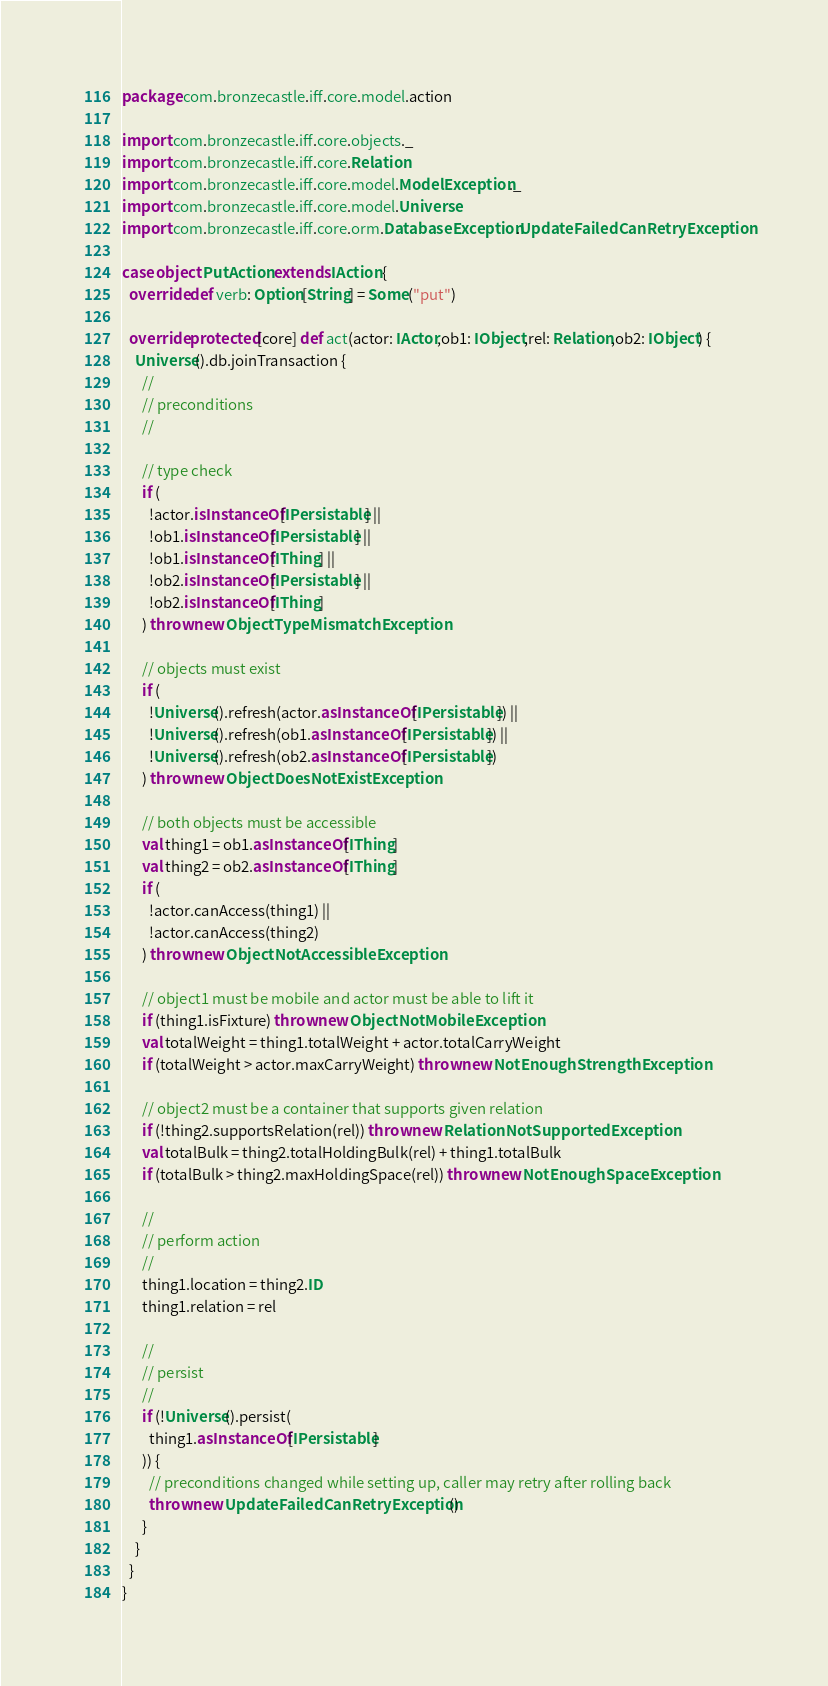<code> <loc_0><loc_0><loc_500><loc_500><_Scala_>package com.bronzecastle.iff.core.model.action

import com.bronzecastle.iff.core.objects._
import com.bronzecastle.iff.core.Relation
import com.bronzecastle.iff.core.model.ModelException._
import com.bronzecastle.iff.core.model.Universe
import com.bronzecastle.iff.core.orm.DatabaseException.UpdateFailedCanRetryException

case object PutAction extends IAction {
  override def verb: Option[String] = Some("put")

  override protected[core] def act(actor: IActor,ob1: IObject,rel: Relation,ob2: IObject) {
    Universe().db.joinTransaction {
      //
      // preconditions
      //

      // type check
      if (
        !actor.isInstanceOf[IPersistable] ||
        !ob1.isInstanceOf[IPersistable] ||
        !ob1.isInstanceOf[IThing] ||
        !ob2.isInstanceOf[IPersistable] ||
        !ob2.isInstanceOf[IThing]
      ) throw new ObjectTypeMismatchException

      // objects must exist
      if (
        !Universe().refresh(actor.asInstanceOf[IPersistable]) ||
        !Universe().refresh(ob1.asInstanceOf[IPersistable]) ||
        !Universe().refresh(ob2.asInstanceOf[IPersistable])
      ) throw new ObjectDoesNotExistException

      // both objects must be accessible
      val thing1 = ob1.asInstanceOf[IThing]
      val thing2 = ob2.asInstanceOf[IThing]
      if (
        !actor.canAccess(thing1) ||
        !actor.canAccess(thing2)
      ) throw new ObjectNotAccessibleException

      // object1 must be mobile and actor must be able to lift it
      if (thing1.isFixture) throw new ObjectNotMobileException
      val totalWeight = thing1.totalWeight + actor.totalCarryWeight
      if (totalWeight > actor.maxCarryWeight) throw new NotEnoughStrengthException

      // object2 must be a container that supports given relation
      if (!thing2.supportsRelation(rel)) throw new RelationNotSupportedException
      val totalBulk = thing2.totalHoldingBulk(rel) + thing1.totalBulk
      if (totalBulk > thing2.maxHoldingSpace(rel)) throw new NotEnoughSpaceException

      //
      // perform action
      //
      thing1.location = thing2.ID
      thing1.relation = rel

      //
      // persist
      //
      if (!Universe().persist(
        thing1.asInstanceOf[IPersistable]
      )) {
        // preconditions changed while setting up, caller may retry after rolling back
        throw new UpdateFailedCanRetryException()
      }
    }
  }
}
</code> 